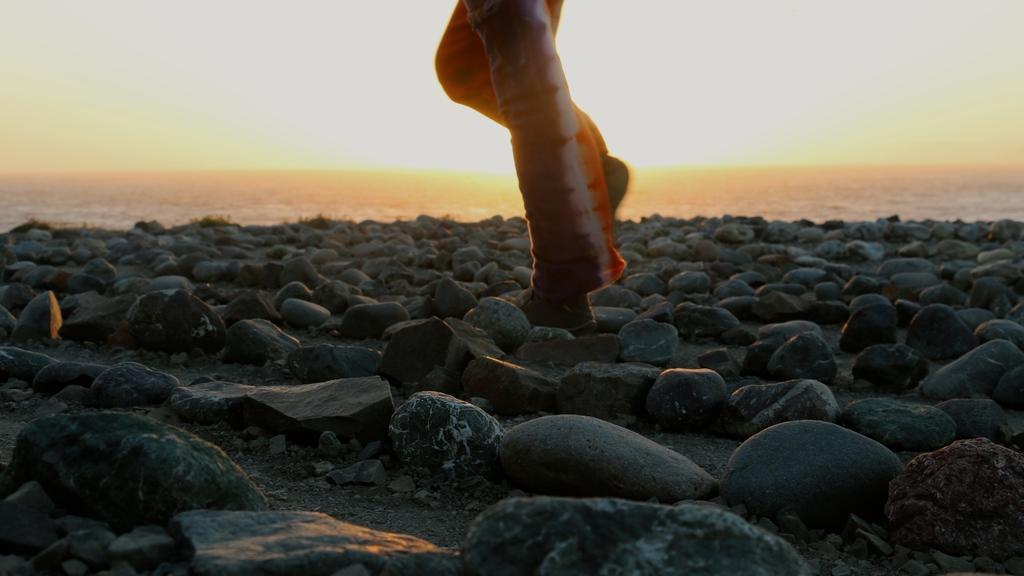How would you summarize this image in a sentence or two? In this image there are rocks, on that rocks there are legs, in the background it's looking like sea. 